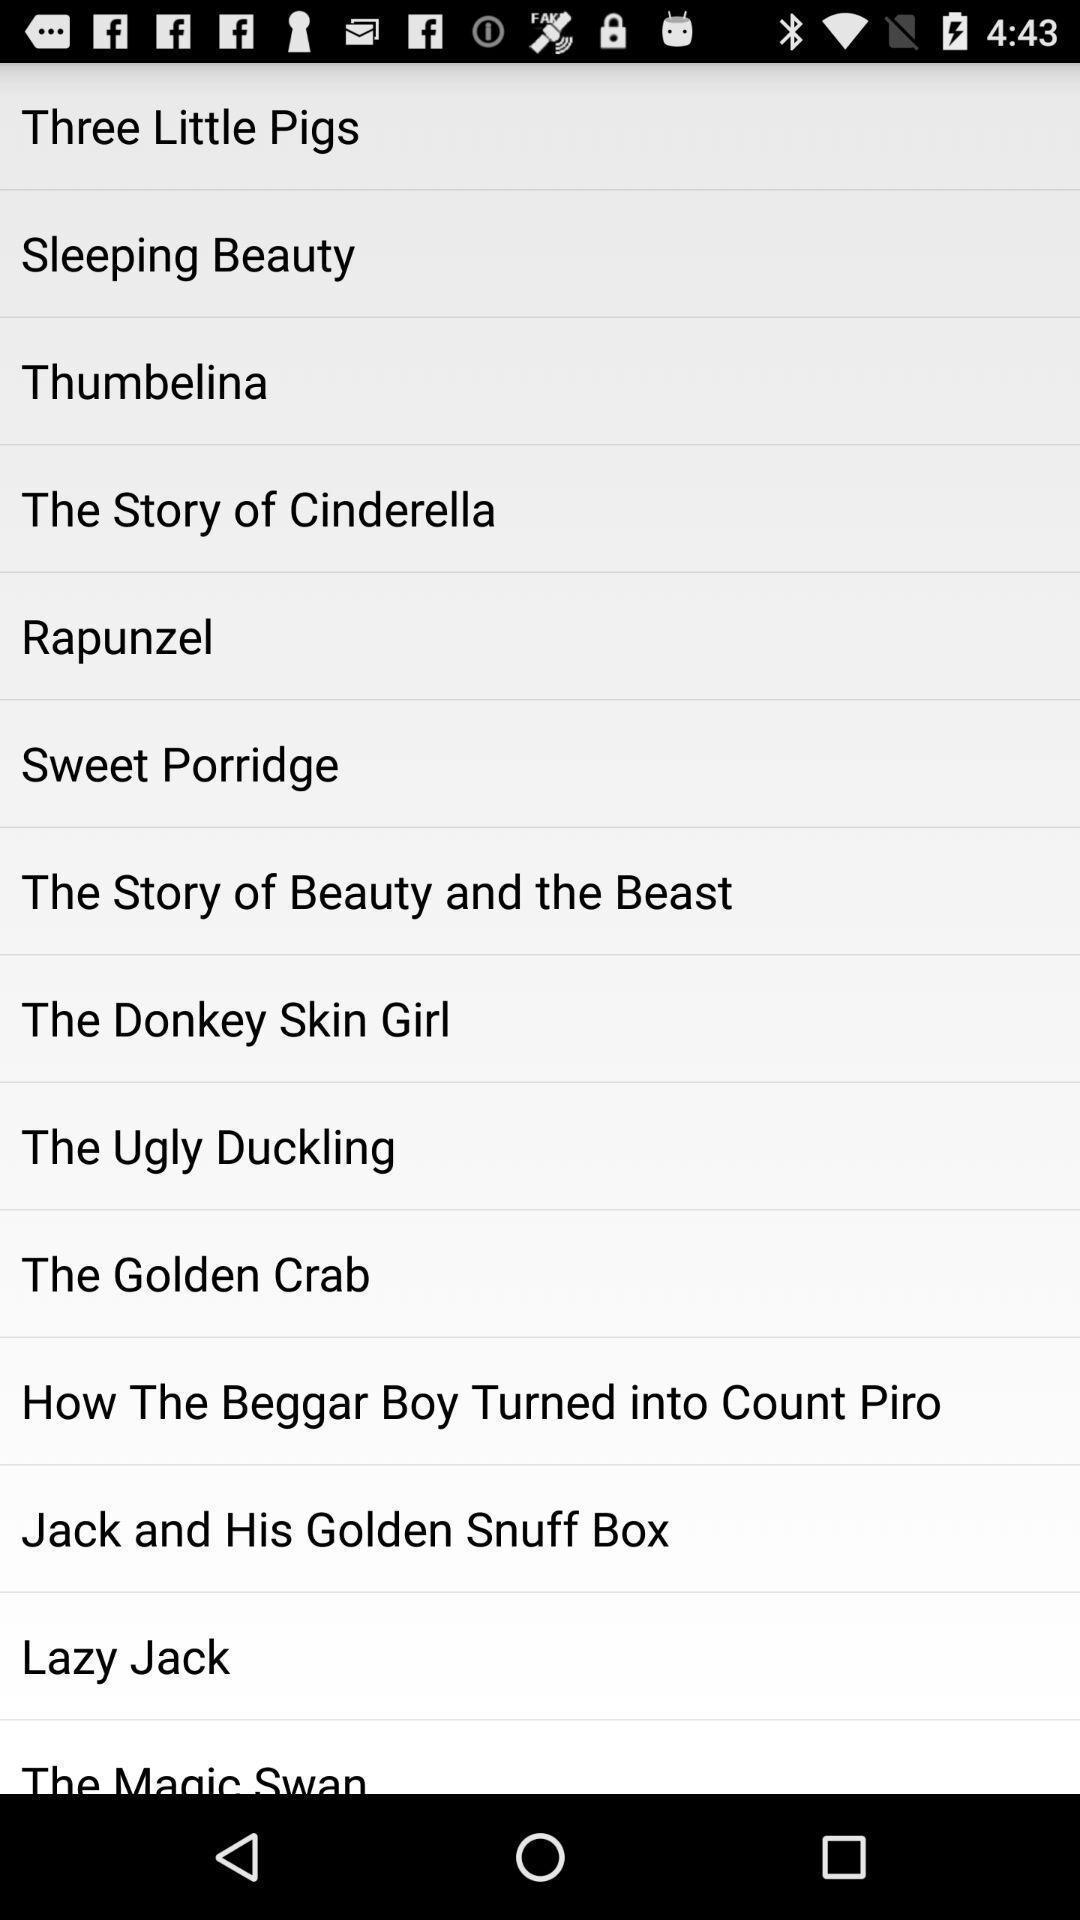Tell me about the visual elements in this screen capture. Screen displaying a list of story titles. 